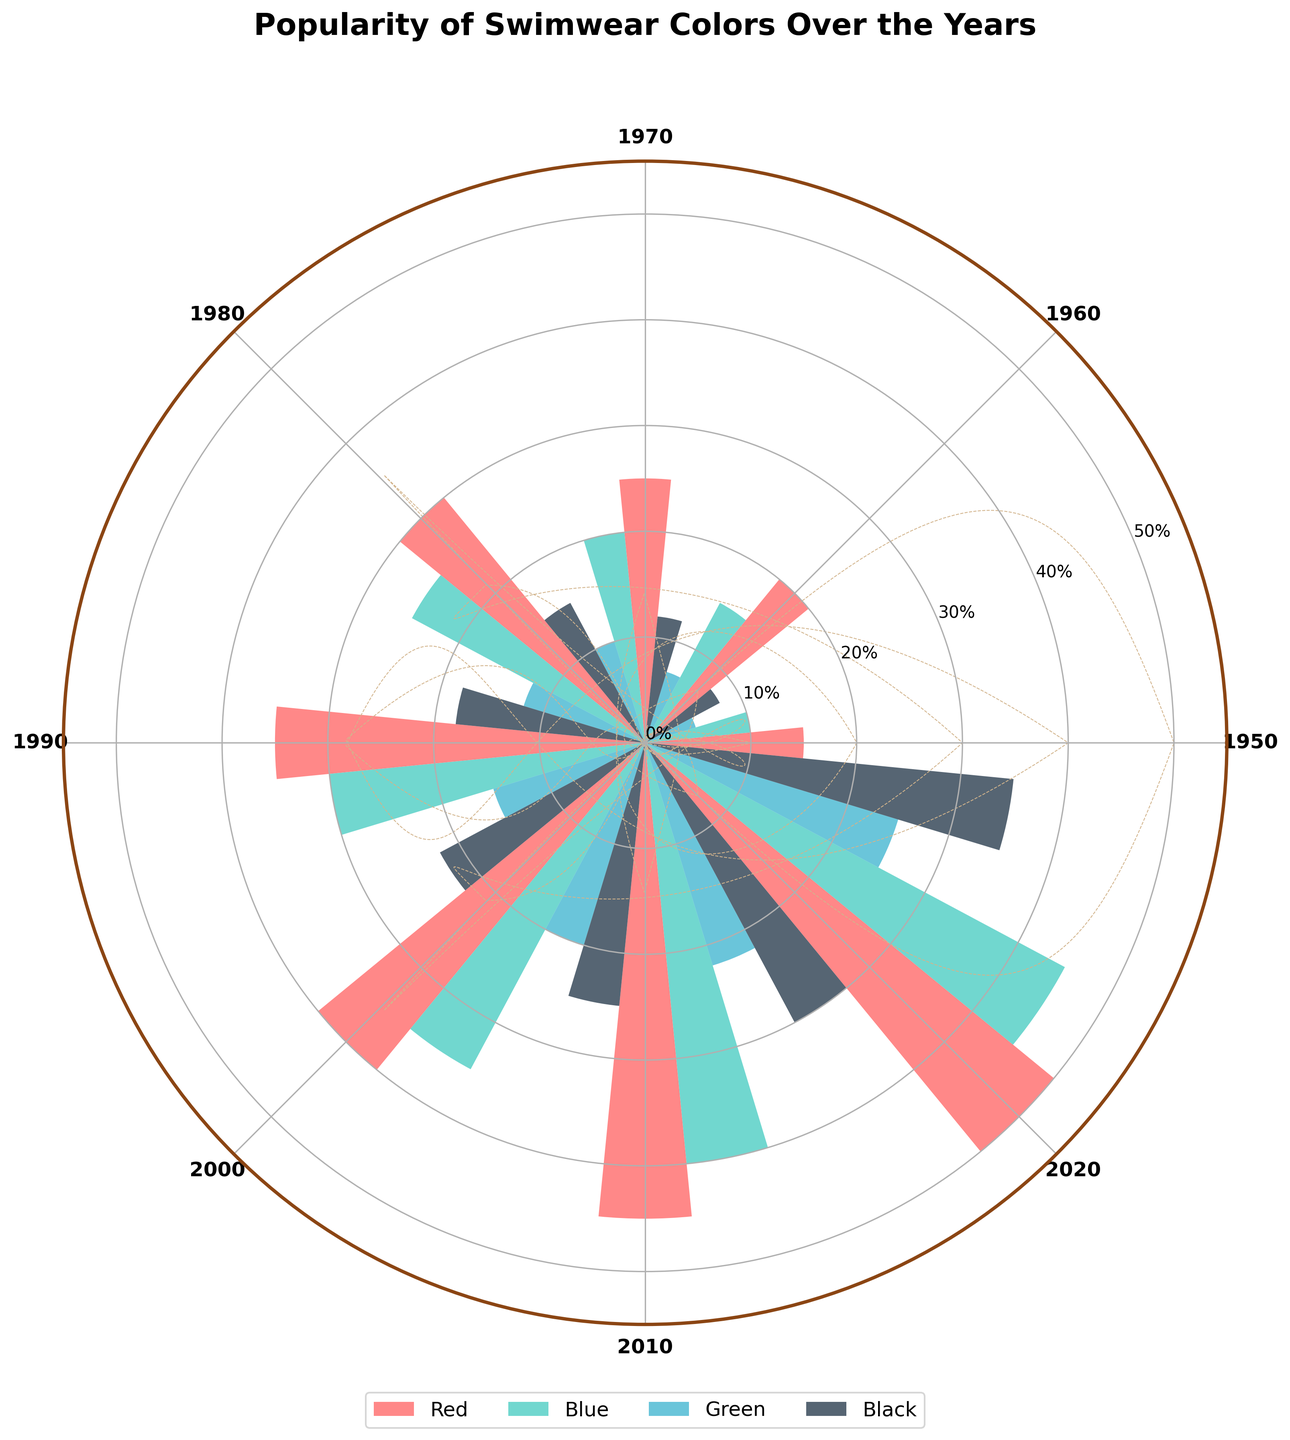Which color was the least popular in 1950? By looking at the section representing 1950, we can compare the values for Red, Blue, Green, and Black. Green has the smallest radii value.
Answer: Green Which year had the highest popularity for Black swimwear? By examining the lengths of the bars for Black across all years, we can see that 2020 has the tallest Black bar.
Answer: 2020 What is the average popularity of Blue swimwear from 1950 to 2020? The popularity values for Blue are 10, 15, 20, 25, 30, 35, 40, and 45. Summing these and dividing by 8, (10+15+20+25+30+35+40+45)/8 = 220/8 = 27.5.
Answer: 27.5 Which color's popularity increased the most from 1950 to 2020? By comparing the popularity values for each color in 1950 and 2020: 
- Red: 15 to 50 (increase of 35) 
- Blue: 10 to 45 (increase of 35) 
- Green: 5 to 25 (increase of 20) 
- Black: 8 to 35 (increase of 27)
Both Red and Blue have the highest increase.
Answer: Red and Blue In 1980, which swimwear color was more popular, Green or Black? In the 1980 section, comparing the lengths of the Green and the Black bars, Black is longer, indicating higher popularity.
Answer: Black What is the trend in the popularity of Red swimwear from 1950 to 2020? Checking the Red bars' lengths from 1950 to 2020, each decade's popularity consistently increases.
Answer: Increasing How much more popular was Blue swimwear than Green in 2000? In 2000, Blue has a value of 35, and Green has 20. The difference is 35 - 20 = 15.
Answer: 15 In which decade did Black swimwear first surpass the 20% popularity mark? Scanning through the Black segments across decades, we see that the first instance surpassing 20% is in 1990.
Answer: 1990 Which color remained consistently less popular than others across all years? By reviewing the entire chart, Green consistently has the shortest bars compared to other colors in every decade.
Answer: Green 